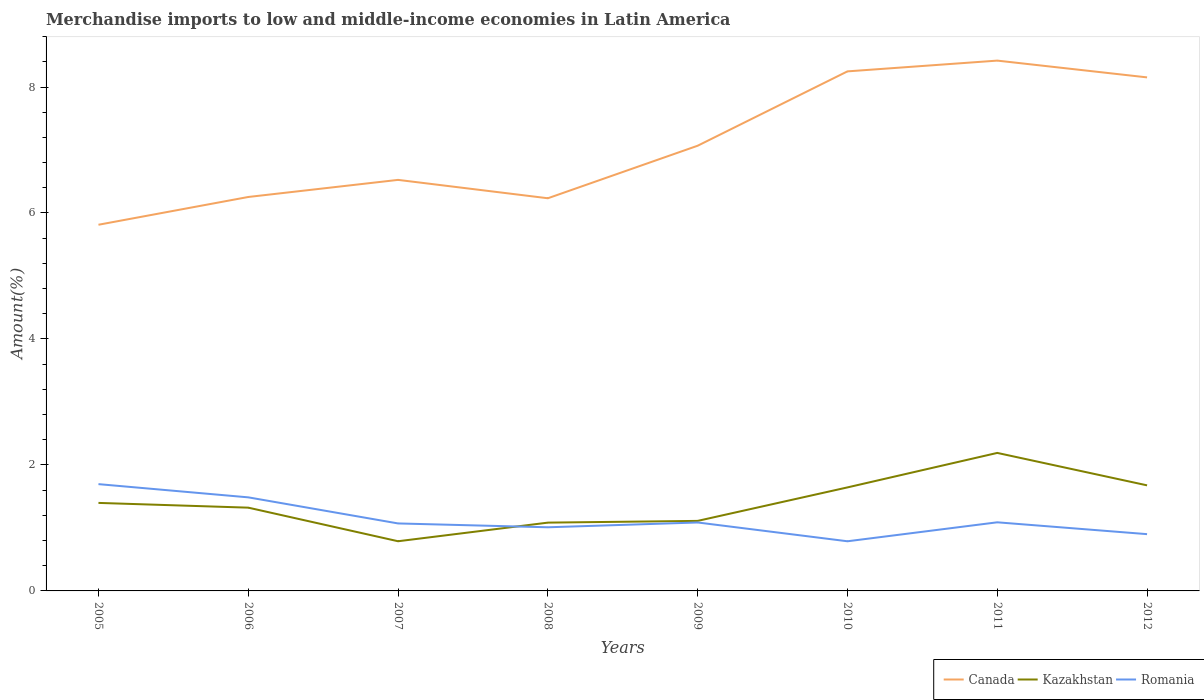How many different coloured lines are there?
Your answer should be compact. 3. Does the line corresponding to Kazakhstan intersect with the line corresponding to Romania?
Your answer should be very brief. Yes. Across all years, what is the maximum percentage of amount earned from merchandise imports in Romania?
Make the answer very short. 0.79. What is the total percentage of amount earned from merchandise imports in Romania in the graph?
Offer a terse response. 0.17. What is the difference between the highest and the second highest percentage of amount earned from merchandise imports in Romania?
Your answer should be very brief. 0.91. What is the difference between the highest and the lowest percentage of amount earned from merchandise imports in Romania?
Offer a terse response. 2. What is the difference between two consecutive major ticks on the Y-axis?
Offer a very short reply. 2. Are the values on the major ticks of Y-axis written in scientific E-notation?
Offer a very short reply. No. Where does the legend appear in the graph?
Your answer should be compact. Bottom right. How many legend labels are there?
Provide a short and direct response. 3. How are the legend labels stacked?
Keep it short and to the point. Horizontal. What is the title of the graph?
Provide a succinct answer. Merchandise imports to low and middle-income economies in Latin America. What is the label or title of the X-axis?
Make the answer very short. Years. What is the label or title of the Y-axis?
Your answer should be compact. Amount(%). What is the Amount(%) in Canada in 2005?
Give a very brief answer. 5.81. What is the Amount(%) in Kazakhstan in 2005?
Your response must be concise. 1.4. What is the Amount(%) of Romania in 2005?
Ensure brevity in your answer.  1.7. What is the Amount(%) in Canada in 2006?
Your response must be concise. 6.25. What is the Amount(%) of Kazakhstan in 2006?
Provide a succinct answer. 1.32. What is the Amount(%) in Romania in 2006?
Keep it short and to the point. 1.49. What is the Amount(%) in Canada in 2007?
Offer a terse response. 6.53. What is the Amount(%) in Kazakhstan in 2007?
Your response must be concise. 0.79. What is the Amount(%) in Romania in 2007?
Your answer should be very brief. 1.07. What is the Amount(%) in Canada in 2008?
Keep it short and to the point. 6.23. What is the Amount(%) in Kazakhstan in 2008?
Ensure brevity in your answer.  1.08. What is the Amount(%) in Romania in 2008?
Offer a very short reply. 1.01. What is the Amount(%) in Canada in 2009?
Offer a very short reply. 7.07. What is the Amount(%) of Kazakhstan in 2009?
Give a very brief answer. 1.11. What is the Amount(%) of Romania in 2009?
Offer a very short reply. 1.09. What is the Amount(%) of Canada in 2010?
Your answer should be compact. 8.25. What is the Amount(%) of Kazakhstan in 2010?
Give a very brief answer. 1.64. What is the Amount(%) of Romania in 2010?
Offer a terse response. 0.79. What is the Amount(%) in Canada in 2011?
Your answer should be compact. 8.42. What is the Amount(%) of Kazakhstan in 2011?
Provide a succinct answer. 2.19. What is the Amount(%) in Romania in 2011?
Make the answer very short. 1.09. What is the Amount(%) in Canada in 2012?
Offer a very short reply. 8.15. What is the Amount(%) in Kazakhstan in 2012?
Provide a short and direct response. 1.68. What is the Amount(%) of Romania in 2012?
Make the answer very short. 0.9. Across all years, what is the maximum Amount(%) in Canada?
Keep it short and to the point. 8.42. Across all years, what is the maximum Amount(%) in Kazakhstan?
Your answer should be compact. 2.19. Across all years, what is the maximum Amount(%) of Romania?
Give a very brief answer. 1.7. Across all years, what is the minimum Amount(%) of Canada?
Provide a short and direct response. 5.81. Across all years, what is the minimum Amount(%) of Kazakhstan?
Your answer should be very brief. 0.79. Across all years, what is the minimum Amount(%) in Romania?
Your response must be concise. 0.79. What is the total Amount(%) in Canada in the graph?
Offer a terse response. 56.72. What is the total Amount(%) of Kazakhstan in the graph?
Offer a terse response. 11.21. What is the total Amount(%) of Romania in the graph?
Make the answer very short. 9.13. What is the difference between the Amount(%) in Canada in 2005 and that in 2006?
Your answer should be compact. -0.44. What is the difference between the Amount(%) in Kazakhstan in 2005 and that in 2006?
Offer a terse response. 0.08. What is the difference between the Amount(%) of Romania in 2005 and that in 2006?
Your response must be concise. 0.21. What is the difference between the Amount(%) in Canada in 2005 and that in 2007?
Keep it short and to the point. -0.71. What is the difference between the Amount(%) in Kazakhstan in 2005 and that in 2007?
Give a very brief answer. 0.61. What is the difference between the Amount(%) in Romania in 2005 and that in 2007?
Offer a very short reply. 0.62. What is the difference between the Amount(%) of Canada in 2005 and that in 2008?
Offer a very short reply. -0.42. What is the difference between the Amount(%) of Kazakhstan in 2005 and that in 2008?
Provide a short and direct response. 0.31. What is the difference between the Amount(%) of Romania in 2005 and that in 2008?
Your answer should be very brief. 0.69. What is the difference between the Amount(%) of Canada in 2005 and that in 2009?
Provide a succinct answer. -1.25. What is the difference between the Amount(%) of Kazakhstan in 2005 and that in 2009?
Your answer should be very brief. 0.29. What is the difference between the Amount(%) of Romania in 2005 and that in 2009?
Offer a very short reply. 0.61. What is the difference between the Amount(%) of Canada in 2005 and that in 2010?
Keep it short and to the point. -2.44. What is the difference between the Amount(%) in Kazakhstan in 2005 and that in 2010?
Offer a very short reply. -0.25. What is the difference between the Amount(%) in Romania in 2005 and that in 2010?
Offer a terse response. 0.91. What is the difference between the Amount(%) of Canada in 2005 and that in 2011?
Provide a succinct answer. -2.61. What is the difference between the Amount(%) in Kazakhstan in 2005 and that in 2011?
Offer a terse response. -0.79. What is the difference between the Amount(%) of Romania in 2005 and that in 2011?
Your response must be concise. 0.61. What is the difference between the Amount(%) of Canada in 2005 and that in 2012?
Give a very brief answer. -2.34. What is the difference between the Amount(%) of Kazakhstan in 2005 and that in 2012?
Keep it short and to the point. -0.28. What is the difference between the Amount(%) of Romania in 2005 and that in 2012?
Keep it short and to the point. 0.79. What is the difference between the Amount(%) in Canada in 2006 and that in 2007?
Ensure brevity in your answer.  -0.27. What is the difference between the Amount(%) of Kazakhstan in 2006 and that in 2007?
Make the answer very short. 0.53. What is the difference between the Amount(%) of Romania in 2006 and that in 2007?
Provide a short and direct response. 0.41. What is the difference between the Amount(%) of Canada in 2006 and that in 2008?
Your answer should be very brief. 0.02. What is the difference between the Amount(%) in Kazakhstan in 2006 and that in 2008?
Your response must be concise. 0.24. What is the difference between the Amount(%) of Romania in 2006 and that in 2008?
Keep it short and to the point. 0.48. What is the difference between the Amount(%) of Canada in 2006 and that in 2009?
Your answer should be compact. -0.81. What is the difference between the Amount(%) in Kazakhstan in 2006 and that in 2009?
Provide a short and direct response. 0.21. What is the difference between the Amount(%) in Romania in 2006 and that in 2009?
Provide a succinct answer. 0.4. What is the difference between the Amount(%) in Canada in 2006 and that in 2010?
Give a very brief answer. -1.99. What is the difference between the Amount(%) of Kazakhstan in 2006 and that in 2010?
Offer a very short reply. -0.32. What is the difference between the Amount(%) of Romania in 2006 and that in 2010?
Offer a terse response. 0.7. What is the difference between the Amount(%) in Canada in 2006 and that in 2011?
Give a very brief answer. -2.17. What is the difference between the Amount(%) in Kazakhstan in 2006 and that in 2011?
Your answer should be compact. -0.87. What is the difference between the Amount(%) of Romania in 2006 and that in 2011?
Offer a very short reply. 0.4. What is the difference between the Amount(%) in Canada in 2006 and that in 2012?
Provide a succinct answer. -1.9. What is the difference between the Amount(%) in Kazakhstan in 2006 and that in 2012?
Offer a terse response. -0.35. What is the difference between the Amount(%) in Romania in 2006 and that in 2012?
Give a very brief answer. 0.58. What is the difference between the Amount(%) of Canada in 2007 and that in 2008?
Ensure brevity in your answer.  0.29. What is the difference between the Amount(%) in Kazakhstan in 2007 and that in 2008?
Offer a very short reply. -0.3. What is the difference between the Amount(%) of Romania in 2007 and that in 2008?
Give a very brief answer. 0.06. What is the difference between the Amount(%) in Canada in 2007 and that in 2009?
Keep it short and to the point. -0.54. What is the difference between the Amount(%) of Kazakhstan in 2007 and that in 2009?
Offer a terse response. -0.32. What is the difference between the Amount(%) of Romania in 2007 and that in 2009?
Make the answer very short. -0.02. What is the difference between the Amount(%) in Canada in 2007 and that in 2010?
Provide a succinct answer. -1.72. What is the difference between the Amount(%) of Kazakhstan in 2007 and that in 2010?
Give a very brief answer. -0.85. What is the difference between the Amount(%) in Romania in 2007 and that in 2010?
Ensure brevity in your answer.  0.28. What is the difference between the Amount(%) of Canada in 2007 and that in 2011?
Offer a terse response. -1.89. What is the difference between the Amount(%) of Kazakhstan in 2007 and that in 2011?
Make the answer very short. -1.4. What is the difference between the Amount(%) in Romania in 2007 and that in 2011?
Your answer should be compact. -0.02. What is the difference between the Amount(%) in Canada in 2007 and that in 2012?
Provide a short and direct response. -1.63. What is the difference between the Amount(%) in Kazakhstan in 2007 and that in 2012?
Give a very brief answer. -0.89. What is the difference between the Amount(%) in Romania in 2007 and that in 2012?
Provide a succinct answer. 0.17. What is the difference between the Amount(%) in Canada in 2008 and that in 2009?
Your response must be concise. -0.83. What is the difference between the Amount(%) in Kazakhstan in 2008 and that in 2009?
Ensure brevity in your answer.  -0.03. What is the difference between the Amount(%) of Romania in 2008 and that in 2009?
Keep it short and to the point. -0.08. What is the difference between the Amount(%) of Canada in 2008 and that in 2010?
Your answer should be compact. -2.01. What is the difference between the Amount(%) in Kazakhstan in 2008 and that in 2010?
Make the answer very short. -0.56. What is the difference between the Amount(%) of Romania in 2008 and that in 2010?
Ensure brevity in your answer.  0.22. What is the difference between the Amount(%) of Canada in 2008 and that in 2011?
Your answer should be very brief. -2.19. What is the difference between the Amount(%) of Kazakhstan in 2008 and that in 2011?
Ensure brevity in your answer.  -1.11. What is the difference between the Amount(%) of Romania in 2008 and that in 2011?
Ensure brevity in your answer.  -0.08. What is the difference between the Amount(%) of Canada in 2008 and that in 2012?
Make the answer very short. -1.92. What is the difference between the Amount(%) of Kazakhstan in 2008 and that in 2012?
Ensure brevity in your answer.  -0.59. What is the difference between the Amount(%) of Romania in 2008 and that in 2012?
Your answer should be very brief. 0.11. What is the difference between the Amount(%) in Canada in 2009 and that in 2010?
Provide a short and direct response. -1.18. What is the difference between the Amount(%) of Kazakhstan in 2009 and that in 2010?
Offer a terse response. -0.53. What is the difference between the Amount(%) in Romania in 2009 and that in 2010?
Give a very brief answer. 0.3. What is the difference between the Amount(%) of Canada in 2009 and that in 2011?
Offer a terse response. -1.35. What is the difference between the Amount(%) in Kazakhstan in 2009 and that in 2011?
Your answer should be very brief. -1.08. What is the difference between the Amount(%) of Romania in 2009 and that in 2011?
Give a very brief answer. -0. What is the difference between the Amount(%) of Canada in 2009 and that in 2012?
Your answer should be very brief. -1.09. What is the difference between the Amount(%) of Kazakhstan in 2009 and that in 2012?
Your answer should be very brief. -0.56. What is the difference between the Amount(%) of Romania in 2009 and that in 2012?
Provide a succinct answer. 0.19. What is the difference between the Amount(%) of Canada in 2010 and that in 2011?
Keep it short and to the point. -0.17. What is the difference between the Amount(%) of Kazakhstan in 2010 and that in 2011?
Offer a terse response. -0.55. What is the difference between the Amount(%) of Romania in 2010 and that in 2011?
Your response must be concise. -0.3. What is the difference between the Amount(%) of Canada in 2010 and that in 2012?
Your answer should be very brief. 0.1. What is the difference between the Amount(%) of Kazakhstan in 2010 and that in 2012?
Your answer should be compact. -0.03. What is the difference between the Amount(%) of Romania in 2010 and that in 2012?
Provide a succinct answer. -0.11. What is the difference between the Amount(%) in Canada in 2011 and that in 2012?
Give a very brief answer. 0.27. What is the difference between the Amount(%) of Kazakhstan in 2011 and that in 2012?
Your answer should be very brief. 0.52. What is the difference between the Amount(%) in Romania in 2011 and that in 2012?
Your answer should be compact. 0.19. What is the difference between the Amount(%) of Canada in 2005 and the Amount(%) of Kazakhstan in 2006?
Your answer should be very brief. 4.49. What is the difference between the Amount(%) in Canada in 2005 and the Amount(%) in Romania in 2006?
Offer a terse response. 4.33. What is the difference between the Amount(%) in Kazakhstan in 2005 and the Amount(%) in Romania in 2006?
Your answer should be very brief. -0.09. What is the difference between the Amount(%) of Canada in 2005 and the Amount(%) of Kazakhstan in 2007?
Ensure brevity in your answer.  5.02. What is the difference between the Amount(%) of Canada in 2005 and the Amount(%) of Romania in 2007?
Ensure brevity in your answer.  4.74. What is the difference between the Amount(%) in Kazakhstan in 2005 and the Amount(%) in Romania in 2007?
Your response must be concise. 0.33. What is the difference between the Amount(%) in Canada in 2005 and the Amount(%) in Kazakhstan in 2008?
Provide a succinct answer. 4.73. What is the difference between the Amount(%) in Canada in 2005 and the Amount(%) in Romania in 2008?
Provide a short and direct response. 4.8. What is the difference between the Amount(%) of Kazakhstan in 2005 and the Amount(%) of Romania in 2008?
Your answer should be very brief. 0.39. What is the difference between the Amount(%) in Canada in 2005 and the Amount(%) in Kazakhstan in 2009?
Provide a succinct answer. 4.7. What is the difference between the Amount(%) of Canada in 2005 and the Amount(%) of Romania in 2009?
Your response must be concise. 4.73. What is the difference between the Amount(%) of Kazakhstan in 2005 and the Amount(%) of Romania in 2009?
Your answer should be very brief. 0.31. What is the difference between the Amount(%) in Canada in 2005 and the Amount(%) in Kazakhstan in 2010?
Offer a very short reply. 4.17. What is the difference between the Amount(%) of Canada in 2005 and the Amount(%) of Romania in 2010?
Your response must be concise. 5.03. What is the difference between the Amount(%) in Kazakhstan in 2005 and the Amount(%) in Romania in 2010?
Provide a short and direct response. 0.61. What is the difference between the Amount(%) of Canada in 2005 and the Amount(%) of Kazakhstan in 2011?
Your answer should be very brief. 3.62. What is the difference between the Amount(%) in Canada in 2005 and the Amount(%) in Romania in 2011?
Give a very brief answer. 4.72. What is the difference between the Amount(%) in Kazakhstan in 2005 and the Amount(%) in Romania in 2011?
Offer a terse response. 0.31. What is the difference between the Amount(%) of Canada in 2005 and the Amount(%) of Kazakhstan in 2012?
Your response must be concise. 4.14. What is the difference between the Amount(%) in Canada in 2005 and the Amount(%) in Romania in 2012?
Your answer should be very brief. 4.91. What is the difference between the Amount(%) in Kazakhstan in 2005 and the Amount(%) in Romania in 2012?
Offer a terse response. 0.5. What is the difference between the Amount(%) of Canada in 2006 and the Amount(%) of Kazakhstan in 2007?
Your response must be concise. 5.47. What is the difference between the Amount(%) in Canada in 2006 and the Amount(%) in Romania in 2007?
Provide a short and direct response. 5.18. What is the difference between the Amount(%) of Kazakhstan in 2006 and the Amount(%) of Romania in 2007?
Ensure brevity in your answer.  0.25. What is the difference between the Amount(%) of Canada in 2006 and the Amount(%) of Kazakhstan in 2008?
Offer a terse response. 5.17. What is the difference between the Amount(%) of Canada in 2006 and the Amount(%) of Romania in 2008?
Provide a short and direct response. 5.24. What is the difference between the Amount(%) of Kazakhstan in 2006 and the Amount(%) of Romania in 2008?
Give a very brief answer. 0.31. What is the difference between the Amount(%) of Canada in 2006 and the Amount(%) of Kazakhstan in 2009?
Give a very brief answer. 5.14. What is the difference between the Amount(%) in Canada in 2006 and the Amount(%) in Romania in 2009?
Your answer should be compact. 5.17. What is the difference between the Amount(%) of Kazakhstan in 2006 and the Amount(%) of Romania in 2009?
Your response must be concise. 0.24. What is the difference between the Amount(%) of Canada in 2006 and the Amount(%) of Kazakhstan in 2010?
Keep it short and to the point. 4.61. What is the difference between the Amount(%) in Canada in 2006 and the Amount(%) in Romania in 2010?
Your answer should be very brief. 5.47. What is the difference between the Amount(%) in Kazakhstan in 2006 and the Amount(%) in Romania in 2010?
Provide a succinct answer. 0.53. What is the difference between the Amount(%) in Canada in 2006 and the Amount(%) in Kazakhstan in 2011?
Keep it short and to the point. 4.06. What is the difference between the Amount(%) of Canada in 2006 and the Amount(%) of Romania in 2011?
Your answer should be very brief. 5.16. What is the difference between the Amount(%) of Kazakhstan in 2006 and the Amount(%) of Romania in 2011?
Provide a short and direct response. 0.23. What is the difference between the Amount(%) of Canada in 2006 and the Amount(%) of Kazakhstan in 2012?
Provide a succinct answer. 4.58. What is the difference between the Amount(%) of Canada in 2006 and the Amount(%) of Romania in 2012?
Your answer should be very brief. 5.35. What is the difference between the Amount(%) of Kazakhstan in 2006 and the Amount(%) of Romania in 2012?
Give a very brief answer. 0.42. What is the difference between the Amount(%) in Canada in 2007 and the Amount(%) in Kazakhstan in 2008?
Offer a terse response. 5.44. What is the difference between the Amount(%) of Canada in 2007 and the Amount(%) of Romania in 2008?
Ensure brevity in your answer.  5.52. What is the difference between the Amount(%) of Kazakhstan in 2007 and the Amount(%) of Romania in 2008?
Ensure brevity in your answer.  -0.22. What is the difference between the Amount(%) of Canada in 2007 and the Amount(%) of Kazakhstan in 2009?
Your answer should be compact. 5.41. What is the difference between the Amount(%) of Canada in 2007 and the Amount(%) of Romania in 2009?
Ensure brevity in your answer.  5.44. What is the difference between the Amount(%) of Kazakhstan in 2007 and the Amount(%) of Romania in 2009?
Keep it short and to the point. -0.3. What is the difference between the Amount(%) in Canada in 2007 and the Amount(%) in Kazakhstan in 2010?
Your answer should be very brief. 4.88. What is the difference between the Amount(%) in Canada in 2007 and the Amount(%) in Romania in 2010?
Your answer should be compact. 5.74. What is the difference between the Amount(%) of Canada in 2007 and the Amount(%) of Kazakhstan in 2011?
Give a very brief answer. 4.33. What is the difference between the Amount(%) in Canada in 2007 and the Amount(%) in Romania in 2011?
Your answer should be very brief. 5.44. What is the difference between the Amount(%) of Kazakhstan in 2007 and the Amount(%) of Romania in 2011?
Make the answer very short. -0.3. What is the difference between the Amount(%) of Canada in 2007 and the Amount(%) of Kazakhstan in 2012?
Ensure brevity in your answer.  4.85. What is the difference between the Amount(%) of Canada in 2007 and the Amount(%) of Romania in 2012?
Your answer should be very brief. 5.62. What is the difference between the Amount(%) of Kazakhstan in 2007 and the Amount(%) of Romania in 2012?
Ensure brevity in your answer.  -0.11. What is the difference between the Amount(%) of Canada in 2008 and the Amount(%) of Kazakhstan in 2009?
Provide a short and direct response. 5.12. What is the difference between the Amount(%) of Canada in 2008 and the Amount(%) of Romania in 2009?
Keep it short and to the point. 5.15. What is the difference between the Amount(%) in Kazakhstan in 2008 and the Amount(%) in Romania in 2009?
Provide a short and direct response. -0. What is the difference between the Amount(%) of Canada in 2008 and the Amount(%) of Kazakhstan in 2010?
Offer a very short reply. 4.59. What is the difference between the Amount(%) of Canada in 2008 and the Amount(%) of Romania in 2010?
Provide a short and direct response. 5.45. What is the difference between the Amount(%) in Kazakhstan in 2008 and the Amount(%) in Romania in 2010?
Your answer should be very brief. 0.3. What is the difference between the Amount(%) of Canada in 2008 and the Amount(%) of Kazakhstan in 2011?
Ensure brevity in your answer.  4.04. What is the difference between the Amount(%) of Canada in 2008 and the Amount(%) of Romania in 2011?
Ensure brevity in your answer.  5.14. What is the difference between the Amount(%) of Kazakhstan in 2008 and the Amount(%) of Romania in 2011?
Your answer should be compact. -0.01. What is the difference between the Amount(%) of Canada in 2008 and the Amount(%) of Kazakhstan in 2012?
Offer a very short reply. 4.56. What is the difference between the Amount(%) in Canada in 2008 and the Amount(%) in Romania in 2012?
Your answer should be very brief. 5.33. What is the difference between the Amount(%) in Kazakhstan in 2008 and the Amount(%) in Romania in 2012?
Ensure brevity in your answer.  0.18. What is the difference between the Amount(%) in Canada in 2009 and the Amount(%) in Kazakhstan in 2010?
Your answer should be very brief. 5.42. What is the difference between the Amount(%) in Canada in 2009 and the Amount(%) in Romania in 2010?
Offer a terse response. 6.28. What is the difference between the Amount(%) of Kazakhstan in 2009 and the Amount(%) of Romania in 2010?
Your answer should be very brief. 0.32. What is the difference between the Amount(%) in Canada in 2009 and the Amount(%) in Kazakhstan in 2011?
Provide a succinct answer. 4.88. What is the difference between the Amount(%) of Canada in 2009 and the Amount(%) of Romania in 2011?
Keep it short and to the point. 5.98. What is the difference between the Amount(%) in Kazakhstan in 2009 and the Amount(%) in Romania in 2011?
Give a very brief answer. 0.02. What is the difference between the Amount(%) of Canada in 2009 and the Amount(%) of Kazakhstan in 2012?
Your response must be concise. 5.39. What is the difference between the Amount(%) in Canada in 2009 and the Amount(%) in Romania in 2012?
Give a very brief answer. 6.17. What is the difference between the Amount(%) in Kazakhstan in 2009 and the Amount(%) in Romania in 2012?
Ensure brevity in your answer.  0.21. What is the difference between the Amount(%) in Canada in 2010 and the Amount(%) in Kazakhstan in 2011?
Provide a short and direct response. 6.06. What is the difference between the Amount(%) in Canada in 2010 and the Amount(%) in Romania in 2011?
Keep it short and to the point. 7.16. What is the difference between the Amount(%) of Kazakhstan in 2010 and the Amount(%) of Romania in 2011?
Provide a short and direct response. 0.55. What is the difference between the Amount(%) in Canada in 2010 and the Amount(%) in Kazakhstan in 2012?
Make the answer very short. 6.57. What is the difference between the Amount(%) of Canada in 2010 and the Amount(%) of Romania in 2012?
Provide a short and direct response. 7.35. What is the difference between the Amount(%) in Kazakhstan in 2010 and the Amount(%) in Romania in 2012?
Give a very brief answer. 0.74. What is the difference between the Amount(%) of Canada in 2011 and the Amount(%) of Kazakhstan in 2012?
Your answer should be compact. 6.74. What is the difference between the Amount(%) of Canada in 2011 and the Amount(%) of Romania in 2012?
Keep it short and to the point. 7.52. What is the difference between the Amount(%) in Kazakhstan in 2011 and the Amount(%) in Romania in 2012?
Your response must be concise. 1.29. What is the average Amount(%) of Canada per year?
Your answer should be very brief. 7.09. What is the average Amount(%) of Kazakhstan per year?
Keep it short and to the point. 1.4. What is the average Amount(%) in Romania per year?
Your answer should be compact. 1.14. In the year 2005, what is the difference between the Amount(%) in Canada and Amount(%) in Kazakhstan?
Provide a short and direct response. 4.42. In the year 2005, what is the difference between the Amount(%) of Canada and Amount(%) of Romania?
Offer a very short reply. 4.12. In the year 2005, what is the difference between the Amount(%) in Kazakhstan and Amount(%) in Romania?
Offer a very short reply. -0.3. In the year 2006, what is the difference between the Amount(%) of Canada and Amount(%) of Kazakhstan?
Ensure brevity in your answer.  4.93. In the year 2006, what is the difference between the Amount(%) of Canada and Amount(%) of Romania?
Your response must be concise. 4.77. In the year 2006, what is the difference between the Amount(%) of Kazakhstan and Amount(%) of Romania?
Offer a very short reply. -0.16. In the year 2007, what is the difference between the Amount(%) in Canada and Amount(%) in Kazakhstan?
Offer a very short reply. 5.74. In the year 2007, what is the difference between the Amount(%) in Canada and Amount(%) in Romania?
Keep it short and to the point. 5.45. In the year 2007, what is the difference between the Amount(%) in Kazakhstan and Amount(%) in Romania?
Ensure brevity in your answer.  -0.28. In the year 2008, what is the difference between the Amount(%) of Canada and Amount(%) of Kazakhstan?
Your answer should be very brief. 5.15. In the year 2008, what is the difference between the Amount(%) in Canada and Amount(%) in Romania?
Offer a terse response. 5.22. In the year 2008, what is the difference between the Amount(%) of Kazakhstan and Amount(%) of Romania?
Ensure brevity in your answer.  0.07. In the year 2009, what is the difference between the Amount(%) of Canada and Amount(%) of Kazakhstan?
Provide a short and direct response. 5.96. In the year 2009, what is the difference between the Amount(%) in Canada and Amount(%) in Romania?
Ensure brevity in your answer.  5.98. In the year 2009, what is the difference between the Amount(%) of Kazakhstan and Amount(%) of Romania?
Provide a short and direct response. 0.03. In the year 2010, what is the difference between the Amount(%) in Canada and Amount(%) in Kazakhstan?
Your answer should be compact. 6.6. In the year 2010, what is the difference between the Amount(%) in Canada and Amount(%) in Romania?
Your response must be concise. 7.46. In the year 2010, what is the difference between the Amount(%) in Kazakhstan and Amount(%) in Romania?
Make the answer very short. 0.86. In the year 2011, what is the difference between the Amount(%) in Canada and Amount(%) in Kazakhstan?
Give a very brief answer. 6.23. In the year 2011, what is the difference between the Amount(%) in Canada and Amount(%) in Romania?
Your answer should be compact. 7.33. In the year 2011, what is the difference between the Amount(%) in Kazakhstan and Amount(%) in Romania?
Provide a short and direct response. 1.1. In the year 2012, what is the difference between the Amount(%) of Canada and Amount(%) of Kazakhstan?
Your answer should be compact. 6.48. In the year 2012, what is the difference between the Amount(%) in Canada and Amount(%) in Romania?
Offer a very short reply. 7.25. In the year 2012, what is the difference between the Amount(%) of Kazakhstan and Amount(%) of Romania?
Keep it short and to the point. 0.77. What is the ratio of the Amount(%) of Canada in 2005 to that in 2006?
Offer a terse response. 0.93. What is the ratio of the Amount(%) in Kazakhstan in 2005 to that in 2006?
Keep it short and to the point. 1.06. What is the ratio of the Amount(%) of Romania in 2005 to that in 2006?
Keep it short and to the point. 1.14. What is the ratio of the Amount(%) of Canada in 2005 to that in 2007?
Make the answer very short. 0.89. What is the ratio of the Amount(%) of Kazakhstan in 2005 to that in 2007?
Provide a succinct answer. 1.77. What is the ratio of the Amount(%) in Romania in 2005 to that in 2007?
Provide a short and direct response. 1.58. What is the ratio of the Amount(%) in Canada in 2005 to that in 2008?
Provide a succinct answer. 0.93. What is the ratio of the Amount(%) in Kazakhstan in 2005 to that in 2008?
Keep it short and to the point. 1.29. What is the ratio of the Amount(%) of Romania in 2005 to that in 2008?
Provide a short and direct response. 1.68. What is the ratio of the Amount(%) of Canada in 2005 to that in 2009?
Make the answer very short. 0.82. What is the ratio of the Amount(%) of Kazakhstan in 2005 to that in 2009?
Ensure brevity in your answer.  1.26. What is the ratio of the Amount(%) in Romania in 2005 to that in 2009?
Your response must be concise. 1.56. What is the ratio of the Amount(%) in Canada in 2005 to that in 2010?
Give a very brief answer. 0.7. What is the ratio of the Amount(%) in Kazakhstan in 2005 to that in 2010?
Your response must be concise. 0.85. What is the ratio of the Amount(%) of Romania in 2005 to that in 2010?
Keep it short and to the point. 2.15. What is the ratio of the Amount(%) in Canada in 2005 to that in 2011?
Your answer should be compact. 0.69. What is the ratio of the Amount(%) in Kazakhstan in 2005 to that in 2011?
Offer a terse response. 0.64. What is the ratio of the Amount(%) in Romania in 2005 to that in 2011?
Keep it short and to the point. 1.56. What is the ratio of the Amount(%) in Canada in 2005 to that in 2012?
Give a very brief answer. 0.71. What is the ratio of the Amount(%) in Kazakhstan in 2005 to that in 2012?
Make the answer very short. 0.83. What is the ratio of the Amount(%) in Romania in 2005 to that in 2012?
Give a very brief answer. 1.88. What is the ratio of the Amount(%) of Canada in 2006 to that in 2007?
Your answer should be very brief. 0.96. What is the ratio of the Amount(%) of Kazakhstan in 2006 to that in 2007?
Provide a short and direct response. 1.68. What is the ratio of the Amount(%) of Romania in 2006 to that in 2007?
Provide a succinct answer. 1.39. What is the ratio of the Amount(%) in Kazakhstan in 2006 to that in 2008?
Ensure brevity in your answer.  1.22. What is the ratio of the Amount(%) in Romania in 2006 to that in 2008?
Your answer should be compact. 1.47. What is the ratio of the Amount(%) of Canada in 2006 to that in 2009?
Your response must be concise. 0.88. What is the ratio of the Amount(%) in Kazakhstan in 2006 to that in 2009?
Provide a short and direct response. 1.19. What is the ratio of the Amount(%) in Romania in 2006 to that in 2009?
Keep it short and to the point. 1.37. What is the ratio of the Amount(%) in Canada in 2006 to that in 2010?
Offer a very short reply. 0.76. What is the ratio of the Amount(%) in Kazakhstan in 2006 to that in 2010?
Your response must be concise. 0.8. What is the ratio of the Amount(%) in Romania in 2006 to that in 2010?
Provide a succinct answer. 1.88. What is the ratio of the Amount(%) in Canada in 2006 to that in 2011?
Your answer should be very brief. 0.74. What is the ratio of the Amount(%) in Kazakhstan in 2006 to that in 2011?
Ensure brevity in your answer.  0.6. What is the ratio of the Amount(%) in Romania in 2006 to that in 2011?
Provide a succinct answer. 1.36. What is the ratio of the Amount(%) of Canada in 2006 to that in 2012?
Your answer should be compact. 0.77. What is the ratio of the Amount(%) of Kazakhstan in 2006 to that in 2012?
Your answer should be compact. 0.79. What is the ratio of the Amount(%) in Romania in 2006 to that in 2012?
Your response must be concise. 1.65. What is the ratio of the Amount(%) in Canada in 2007 to that in 2008?
Offer a very short reply. 1.05. What is the ratio of the Amount(%) of Kazakhstan in 2007 to that in 2008?
Offer a terse response. 0.73. What is the ratio of the Amount(%) in Romania in 2007 to that in 2008?
Provide a succinct answer. 1.06. What is the ratio of the Amount(%) of Canada in 2007 to that in 2009?
Provide a succinct answer. 0.92. What is the ratio of the Amount(%) in Kazakhstan in 2007 to that in 2009?
Your answer should be very brief. 0.71. What is the ratio of the Amount(%) of Romania in 2007 to that in 2009?
Ensure brevity in your answer.  0.99. What is the ratio of the Amount(%) in Canada in 2007 to that in 2010?
Your answer should be compact. 0.79. What is the ratio of the Amount(%) of Kazakhstan in 2007 to that in 2010?
Give a very brief answer. 0.48. What is the ratio of the Amount(%) in Romania in 2007 to that in 2010?
Your answer should be compact. 1.36. What is the ratio of the Amount(%) of Canada in 2007 to that in 2011?
Offer a very short reply. 0.78. What is the ratio of the Amount(%) of Kazakhstan in 2007 to that in 2011?
Offer a terse response. 0.36. What is the ratio of the Amount(%) of Romania in 2007 to that in 2011?
Your answer should be very brief. 0.98. What is the ratio of the Amount(%) in Canada in 2007 to that in 2012?
Provide a short and direct response. 0.8. What is the ratio of the Amount(%) in Kazakhstan in 2007 to that in 2012?
Ensure brevity in your answer.  0.47. What is the ratio of the Amount(%) in Romania in 2007 to that in 2012?
Offer a very short reply. 1.19. What is the ratio of the Amount(%) in Canada in 2008 to that in 2009?
Your answer should be very brief. 0.88. What is the ratio of the Amount(%) of Kazakhstan in 2008 to that in 2009?
Provide a succinct answer. 0.98. What is the ratio of the Amount(%) in Romania in 2008 to that in 2009?
Your answer should be very brief. 0.93. What is the ratio of the Amount(%) of Canada in 2008 to that in 2010?
Offer a terse response. 0.76. What is the ratio of the Amount(%) in Kazakhstan in 2008 to that in 2010?
Your answer should be compact. 0.66. What is the ratio of the Amount(%) of Romania in 2008 to that in 2010?
Give a very brief answer. 1.28. What is the ratio of the Amount(%) of Canada in 2008 to that in 2011?
Your answer should be compact. 0.74. What is the ratio of the Amount(%) in Kazakhstan in 2008 to that in 2011?
Make the answer very short. 0.49. What is the ratio of the Amount(%) of Romania in 2008 to that in 2011?
Your response must be concise. 0.93. What is the ratio of the Amount(%) of Canada in 2008 to that in 2012?
Keep it short and to the point. 0.76. What is the ratio of the Amount(%) of Kazakhstan in 2008 to that in 2012?
Your response must be concise. 0.65. What is the ratio of the Amount(%) in Romania in 2008 to that in 2012?
Provide a short and direct response. 1.12. What is the ratio of the Amount(%) in Canada in 2009 to that in 2010?
Provide a succinct answer. 0.86. What is the ratio of the Amount(%) in Kazakhstan in 2009 to that in 2010?
Offer a very short reply. 0.68. What is the ratio of the Amount(%) in Romania in 2009 to that in 2010?
Provide a short and direct response. 1.38. What is the ratio of the Amount(%) of Canada in 2009 to that in 2011?
Offer a terse response. 0.84. What is the ratio of the Amount(%) of Kazakhstan in 2009 to that in 2011?
Make the answer very short. 0.51. What is the ratio of the Amount(%) in Romania in 2009 to that in 2011?
Give a very brief answer. 1. What is the ratio of the Amount(%) in Canada in 2009 to that in 2012?
Your answer should be very brief. 0.87. What is the ratio of the Amount(%) of Kazakhstan in 2009 to that in 2012?
Your response must be concise. 0.66. What is the ratio of the Amount(%) in Romania in 2009 to that in 2012?
Provide a succinct answer. 1.21. What is the ratio of the Amount(%) in Canada in 2010 to that in 2011?
Your response must be concise. 0.98. What is the ratio of the Amount(%) in Kazakhstan in 2010 to that in 2011?
Offer a terse response. 0.75. What is the ratio of the Amount(%) of Romania in 2010 to that in 2011?
Offer a very short reply. 0.72. What is the ratio of the Amount(%) of Canada in 2010 to that in 2012?
Provide a short and direct response. 1.01. What is the ratio of the Amount(%) of Kazakhstan in 2010 to that in 2012?
Offer a very short reply. 0.98. What is the ratio of the Amount(%) in Romania in 2010 to that in 2012?
Keep it short and to the point. 0.87. What is the ratio of the Amount(%) of Canada in 2011 to that in 2012?
Offer a terse response. 1.03. What is the ratio of the Amount(%) of Kazakhstan in 2011 to that in 2012?
Give a very brief answer. 1.31. What is the ratio of the Amount(%) in Romania in 2011 to that in 2012?
Ensure brevity in your answer.  1.21. What is the difference between the highest and the second highest Amount(%) of Canada?
Your response must be concise. 0.17. What is the difference between the highest and the second highest Amount(%) in Kazakhstan?
Offer a terse response. 0.52. What is the difference between the highest and the second highest Amount(%) of Romania?
Make the answer very short. 0.21. What is the difference between the highest and the lowest Amount(%) of Canada?
Make the answer very short. 2.61. What is the difference between the highest and the lowest Amount(%) of Kazakhstan?
Your response must be concise. 1.4. What is the difference between the highest and the lowest Amount(%) of Romania?
Provide a short and direct response. 0.91. 